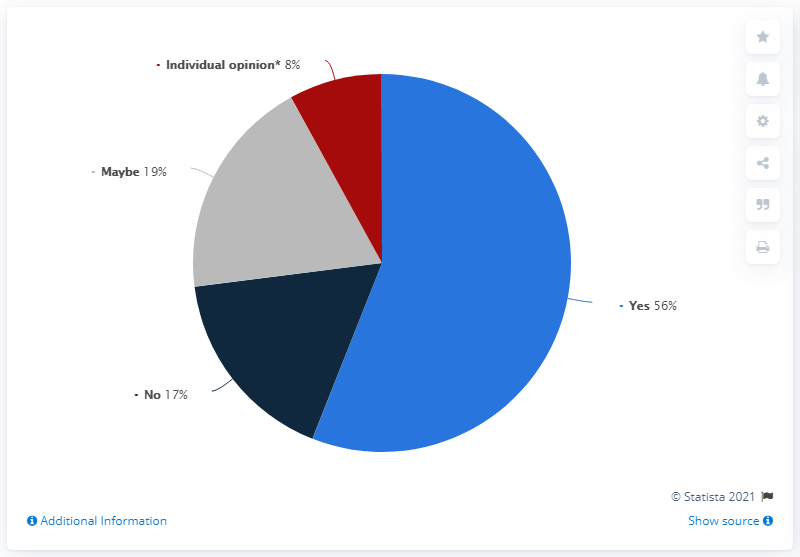Mention a couple of crucial points in this snapshot. What is the most common response? Yes. The sum of responses that are not negative is 83. 